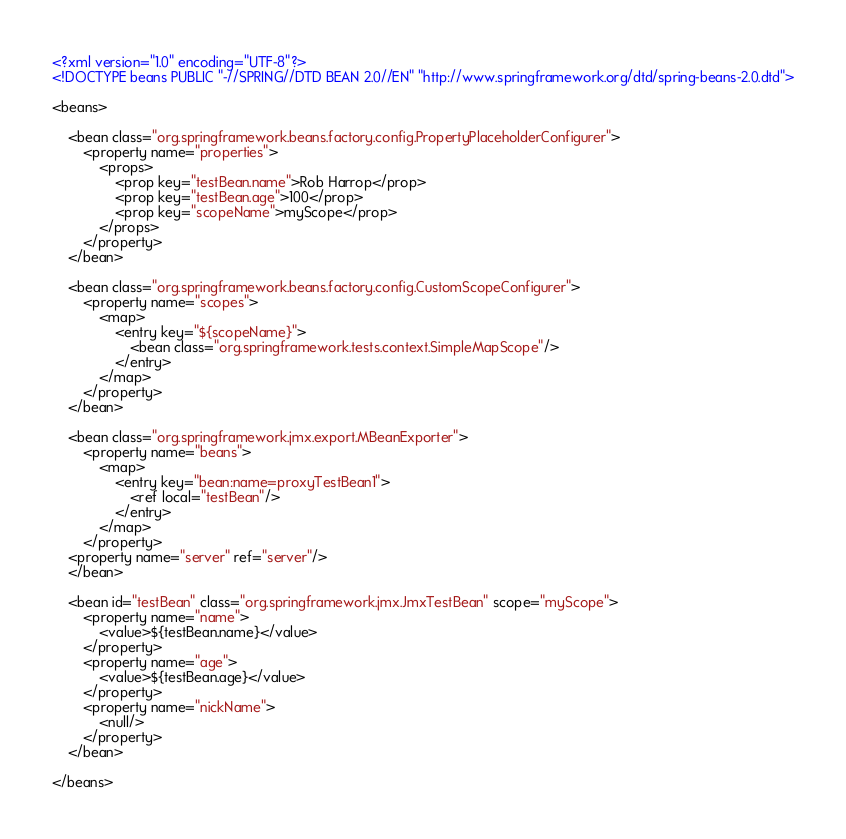<code> <loc_0><loc_0><loc_500><loc_500><_XML_><?xml version="1.0" encoding="UTF-8"?>
<!DOCTYPE beans PUBLIC "-//SPRING//DTD BEAN 2.0//EN" "http://www.springframework.org/dtd/spring-beans-2.0.dtd">

<beans>

	<bean class="org.springframework.beans.factory.config.PropertyPlaceholderConfigurer">
		<property name="properties">
			<props>
				<prop key="testBean.name">Rob Harrop</prop>
				<prop key="testBean.age">100</prop>
				<prop key="scopeName">myScope</prop>
			</props>
		</property>
	</bean>

	<bean class="org.springframework.beans.factory.config.CustomScopeConfigurer">
		<property name="scopes">
			<map>
				<entry key="${scopeName}">
					<bean class="org.springframework.tests.context.SimpleMapScope"/>
				</entry>
			</map>
		</property>
	</bean>

	<bean class="org.springframework.jmx.export.MBeanExporter">
		<property name="beans">
			<map>
				<entry key="bean:name=proxyTestBean1">
					<ref local="testBean"/>
				</entry>
			</map>
		</property>
    <property name="server" ref="server"/>
	</bean>

	<bean id="testBean" class="org.springframework.jmx.JmxTestBean" scope="myScope">
		<property name="name">
			<value>${testBean.name}</value>
		</property>
		<property name="age">
			<value>${testBean.age}</value>
		</property>
		<property name="nickName">
			<null/>
		</property>
	</bean>

</beans>
</code> 